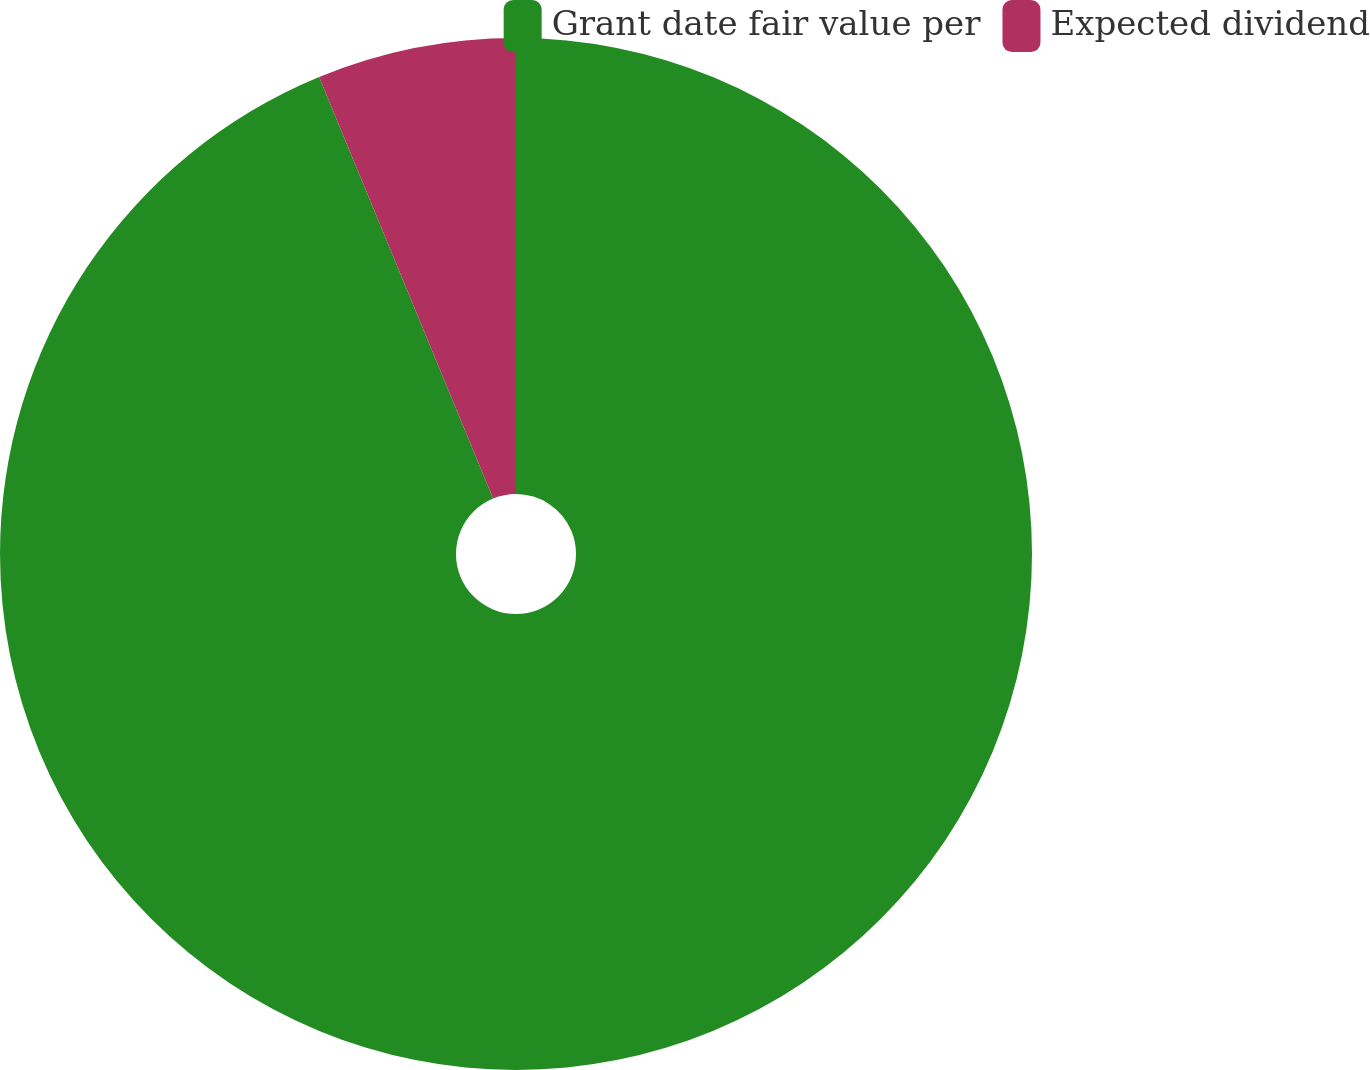Convert chart to OTSL. <chart><loc_0><loc_0><loc_500><loc_500><pie_chart><fcel>Grant date fair value per<fcel>Expected dividend<nl><fcel>93.77%<fcel>6.23%<nl></chart> 